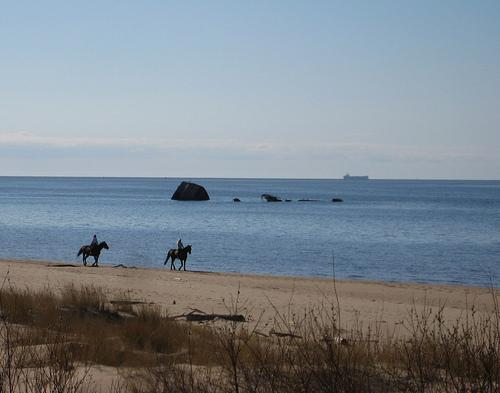Which actor has the training to do what these people are doing?

Choices:
A) russell crowe
B) kevin james
C) gabourey sidibe
D) jacob tremblay russell crowe 